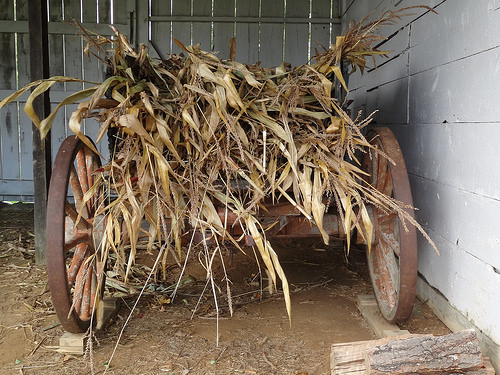<image>
Is the hay above the wagon? No. The hay is not positioned above the wagon. The vertical arrangement shows a different relationship. 